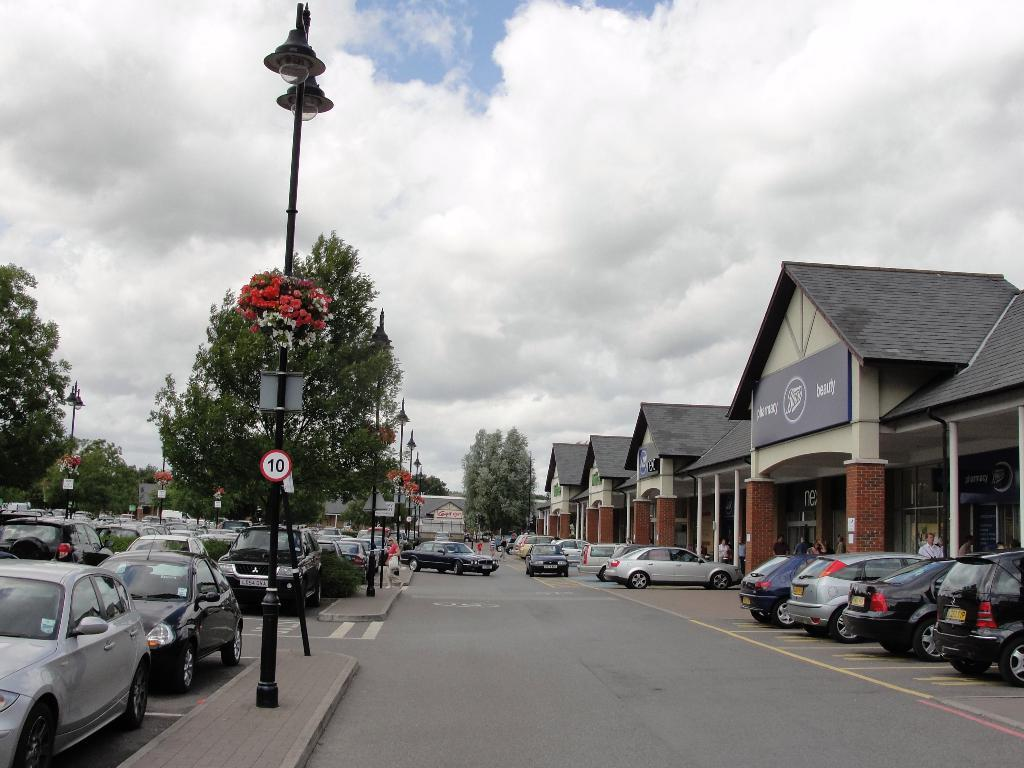What can be seen parked on the road in the image? There are vehicles parked on the road in the image. What structures are present in the image besides the vehicles? There are light poles, boards, trees, and houses in the image. What is visible in the background of the image? The sky with clouds is visible in the background of the image. What type of vessel is being filled with oil in the image? There is no vessel or oil present in the image. What level of water can be seen in the image? There is no water or level mentioned in the image; it features vehicles, light poles, boards, trees, houses, and a sky with clouds. 